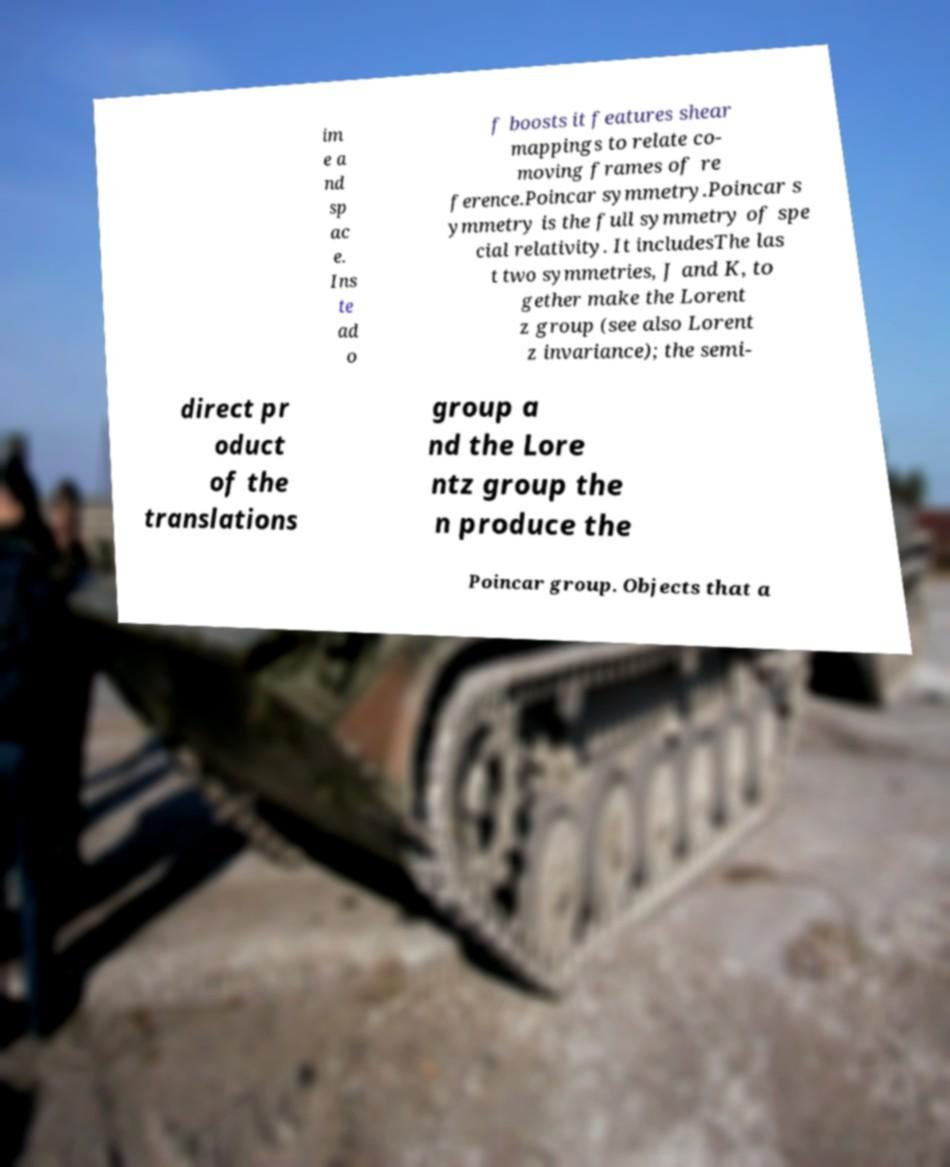Please identify and transcribe the text found in this image. im e a nd sp ac e. Ins te ad o f boosts it features shear mappings to relate co- moving frames of re ference.Poincar symmetry.Poincar s ymmetry is the full symmetry of spe cial relativity. It includesThe las t two symmetries, J and K, to gether make the Lorent z group (see also Lorent z invariance); the semi- direct pr oduct of the translations group a nd the Lore ntz group the n produce the Poincar group. Objects that a 